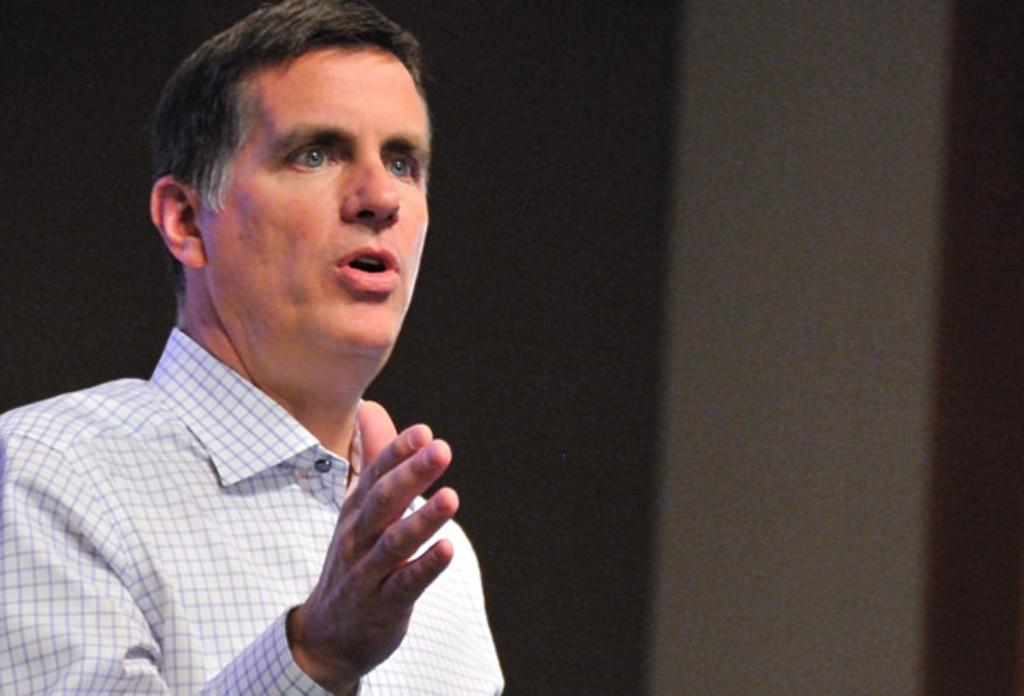Who or what is present on the left side of the image? There is a person on the left side of the image. What can be said about the background of the image? The background of the image is dark in color. Can you describe the setting of the image? The image may have been taken on a stage, based on the provided facts. What type of bun is the person holding in the image? There is no bun present in the image. Can you hear a kitty meowing in the background of the image? There is no audio associated with the image, and no kitty is visible or mentioned in the provided facts. 